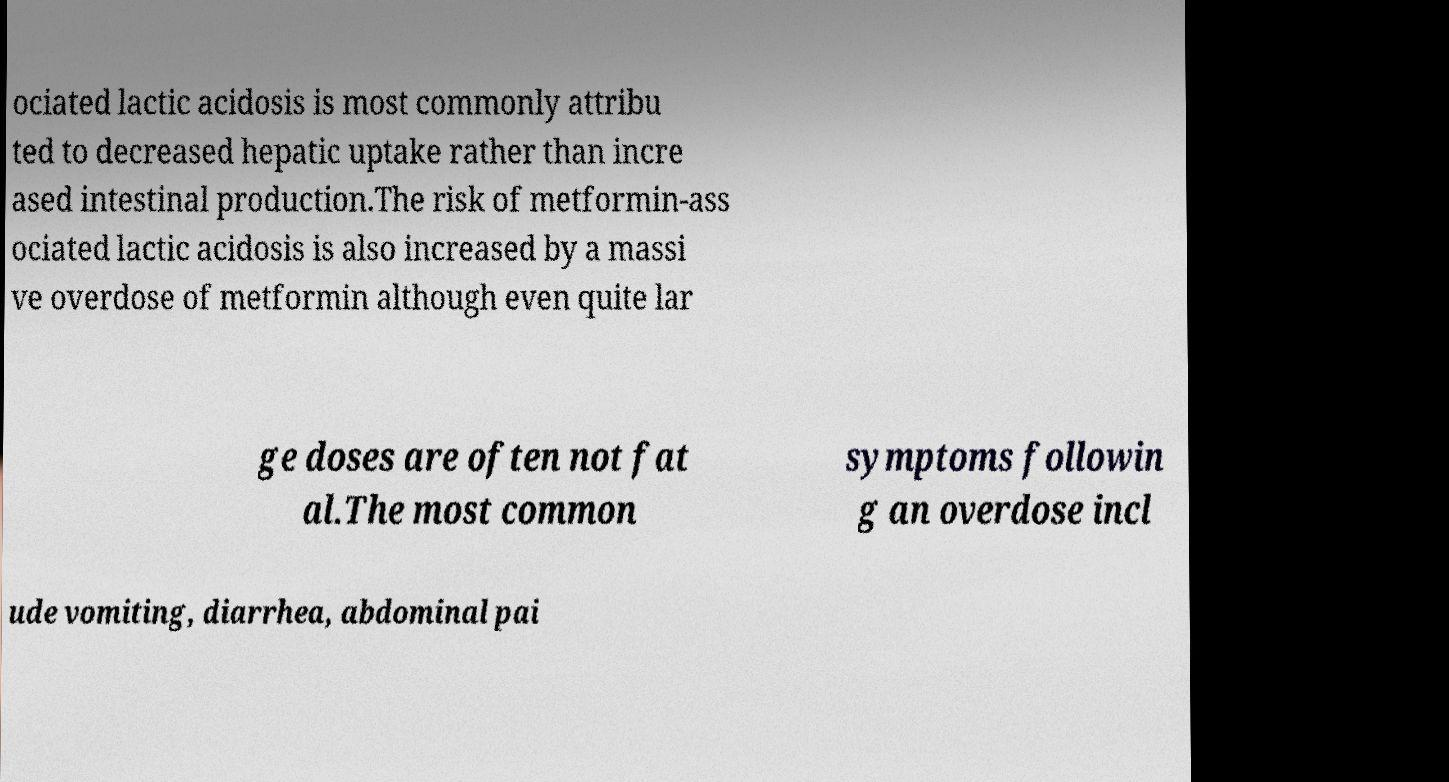Can you accurately transcribe the text from the provided image for me? ociated lactic acidosis is most commonly attribu ted to decreased hepatic uptake rather than incre ased intestinal production.The risk of metformin-ass ociated lactic acidosis is also increased by a massi ve overdose of metformin although even quite lar ge doses are often not fat al.The most common symptoms followin g an overdose incl ude vomiting, diarrhea, abdominal pai 